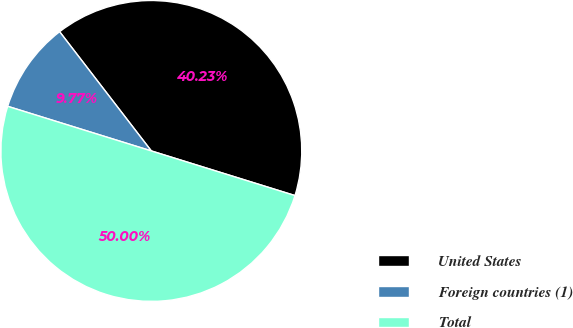<chart> <loc_0><loc_0><loc_500><loc_500><pie_chart><fcel>United States<fcel>Foreign countries (1)<fcel>Total<nl><fcel>40.23%<fcel>9.77%<fcel>50.0%<nl></chart> 